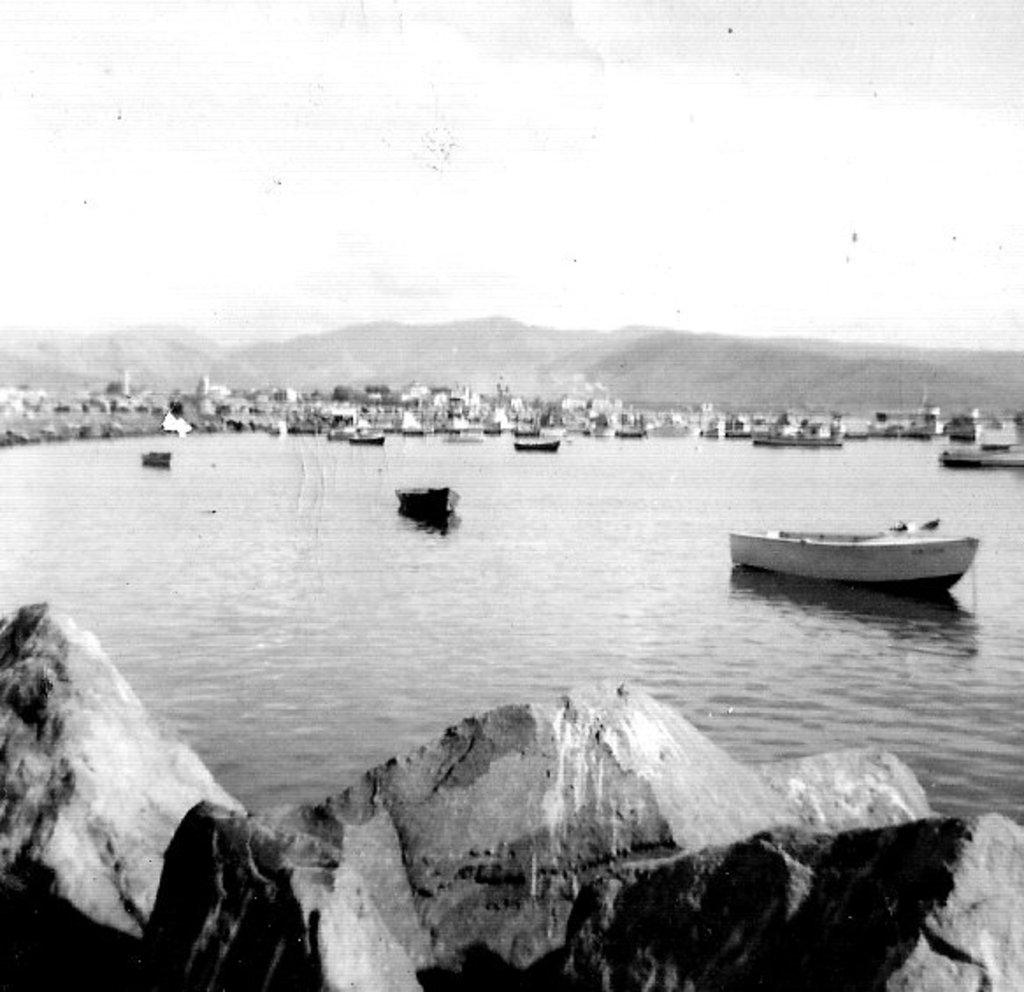What is on the water in the image? There are boats on the water in the image. What can be seen in the background of the image? Buildings, trees, mountains, and the sky are visible in the background. What is present at the bottom of the image? Water and stones are present at the bottom of the image. What type of wool is being used to help the respect grow in the image? There is no wool, respect, or help present in the image; it features boats on water with a background of buildings, trees, mountains, and the sky. 